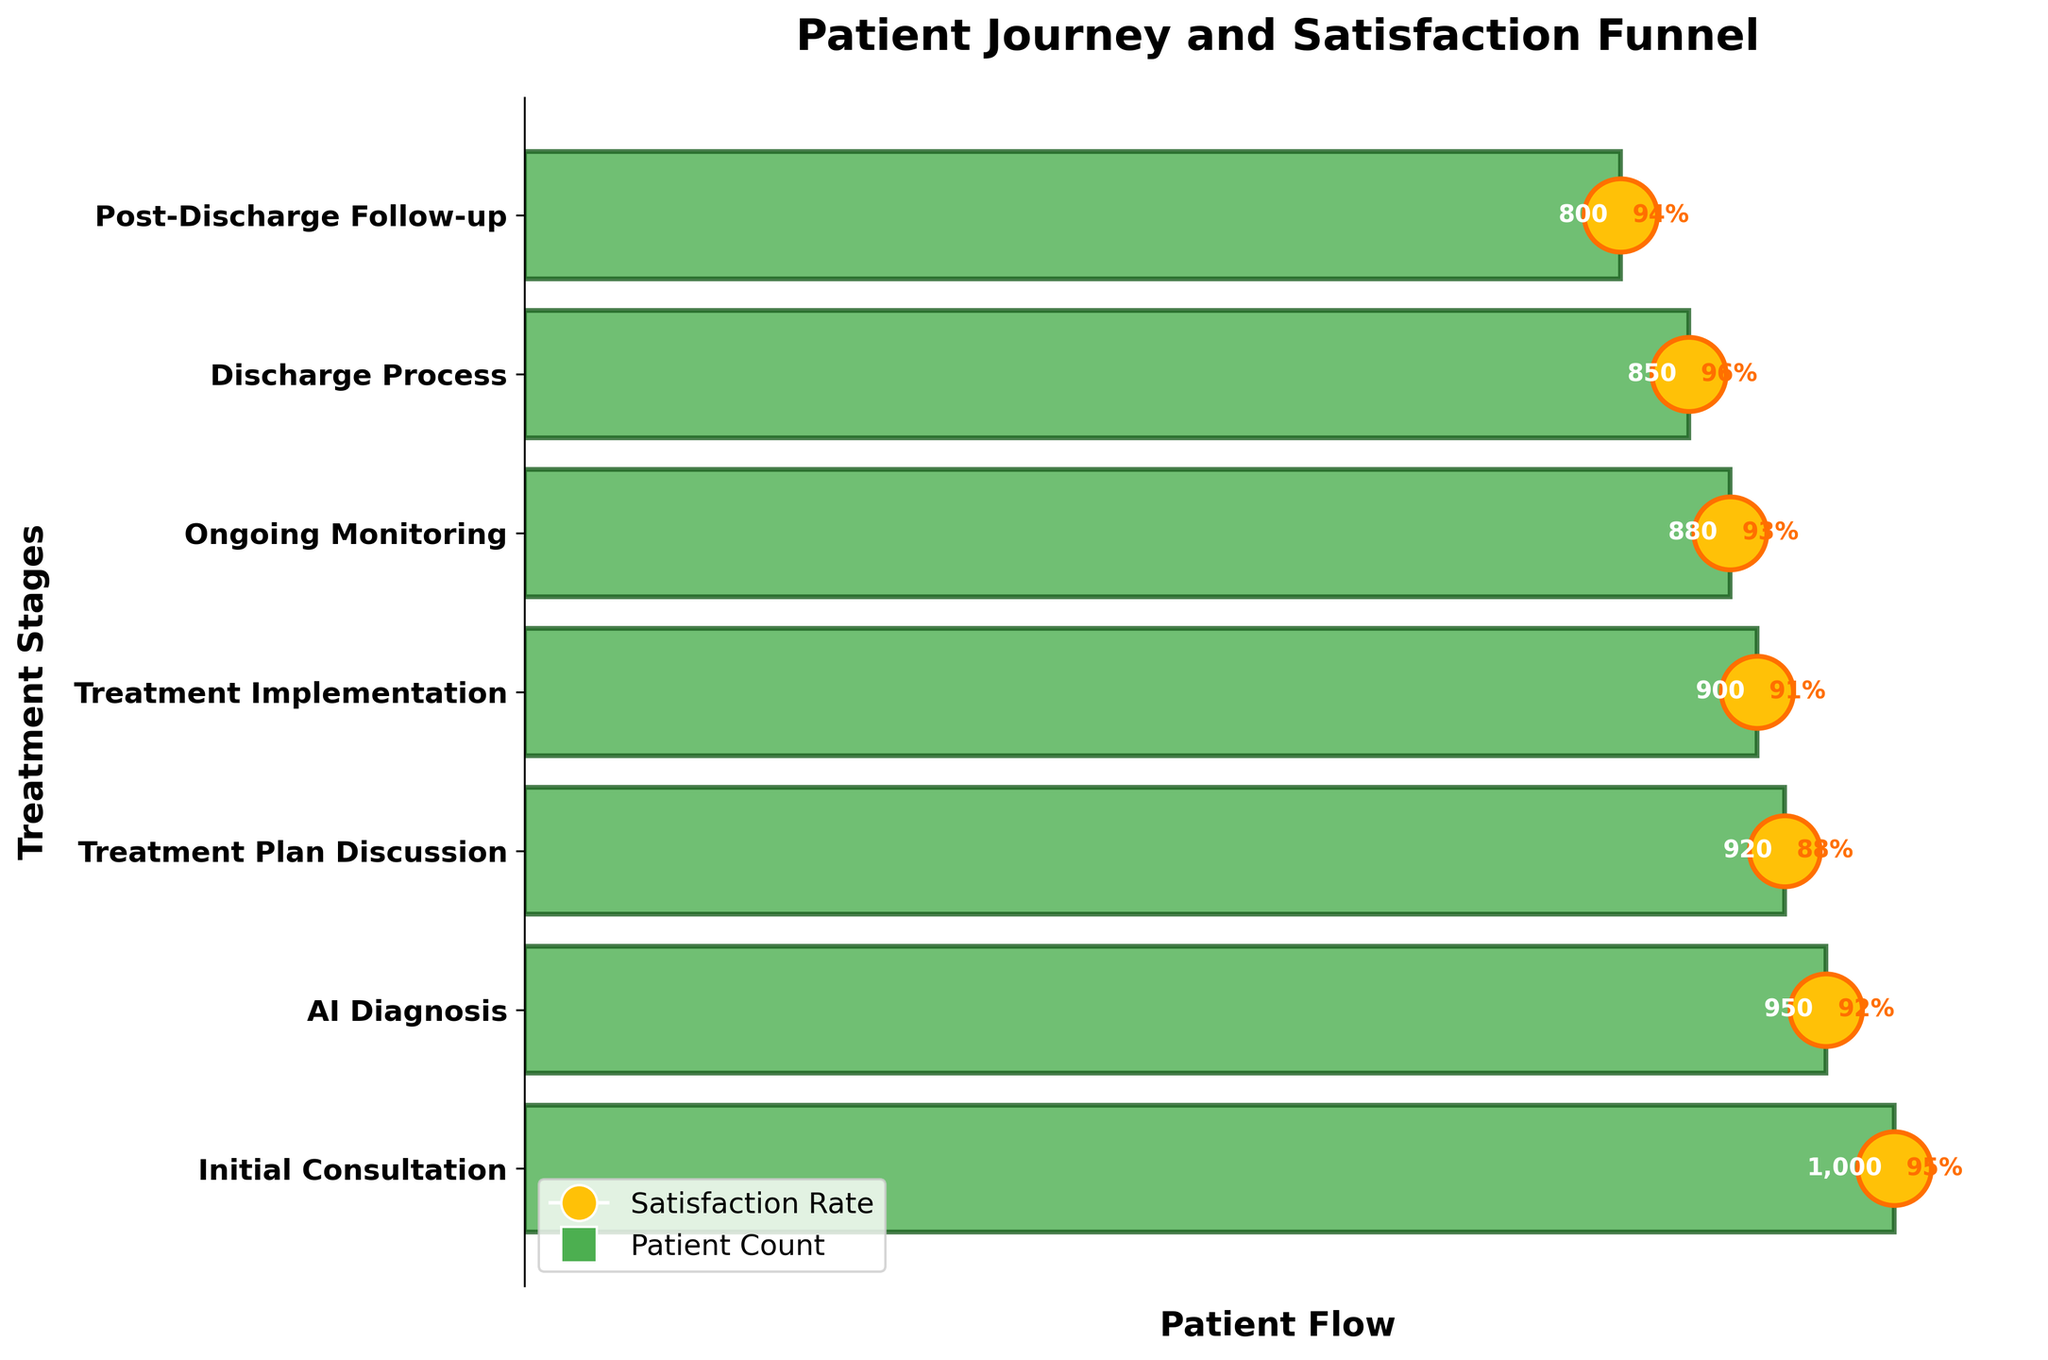What is the title of the chart? The title is given at the top of the chart and generally indicates what the chart represents.
Answer: Patient Journey and Satisfaction Funnel What is the satisfaction rate during the Initial Consultation stage? The satisfaction rate is represented by the percentage annotation on the circle that corresponds to the Initial Consultation stage.
Answer: 95% How many patients were there during the Discharge Process stage? The number of patients is annotated next to the bar corresponding to the Discharge Process stage.
Answer: 850 Which stage has the highest satisfaction rate? Look for the circle with the highest percentage annotation.
Answer: Discharge Process Which stage has the lowest number of patients? Compare the patient numbers annotated next to each bar in the chart.
Answer: Post-Discharge Follow-up How does the satisfaction rate during Treatment Plan Discussion compare to Treatment Implementation? Compare the percentage annotations on the circles for both stages. Treatment Plan Discussion has a satisfaction rate of 88%, and Treatment Implementation has a rate of 91%.
Answer: Treatment Implementation has a higher satisfaction rate What is the average satisfaction rate across all stages? Sum all the satisfaction rates and divide by the number of stages: (95% + 92% + 88% + 91% + 93% + 96% + 94%) / 7. (0.95 + 0.92 + 0.88 + 0.91 + 0.93 + 0.96 + 0.94) / 7 = 6.49 / 7
Answer: 92.7% How many stages are there in the chart? Count the bars on the vertical axis representing each stage.
Answer: 7 By how many patients does the number drop between the Initial Consultation and Post-Discharge Follow-up stages? Subtract the number of patients in the Post-Discharge Follow-up stage from the number of patients in the Initial Consultation stage: 1000 - 800 = 200.
Answer: 200 What stage has the largest decrease in patient count compared to the previous stage? Calculate the difference for each stage and identify the largest one: 
Initial Consultation to AI Diagnosis: 1000 - 950 = 50
AI Diagnosis to Treatment Plan Discussion: 950 - 920 = 30
Treatment Plan Discussion to Treatment Implementation: 920 - 900 = 20
Treatment Implementation to Ongoing Monitoring: 900 - 880 = 20
Ongoing Monitoring to Discharge Process: 880 - 850 = 30
Discharge Process to Post-Discharge Follow-up: 850 - 800 = 50
The largest decrease is between Initial Consultation and AI Diagnosis.
Answer: Initial Consultation to AI Diagnosis 